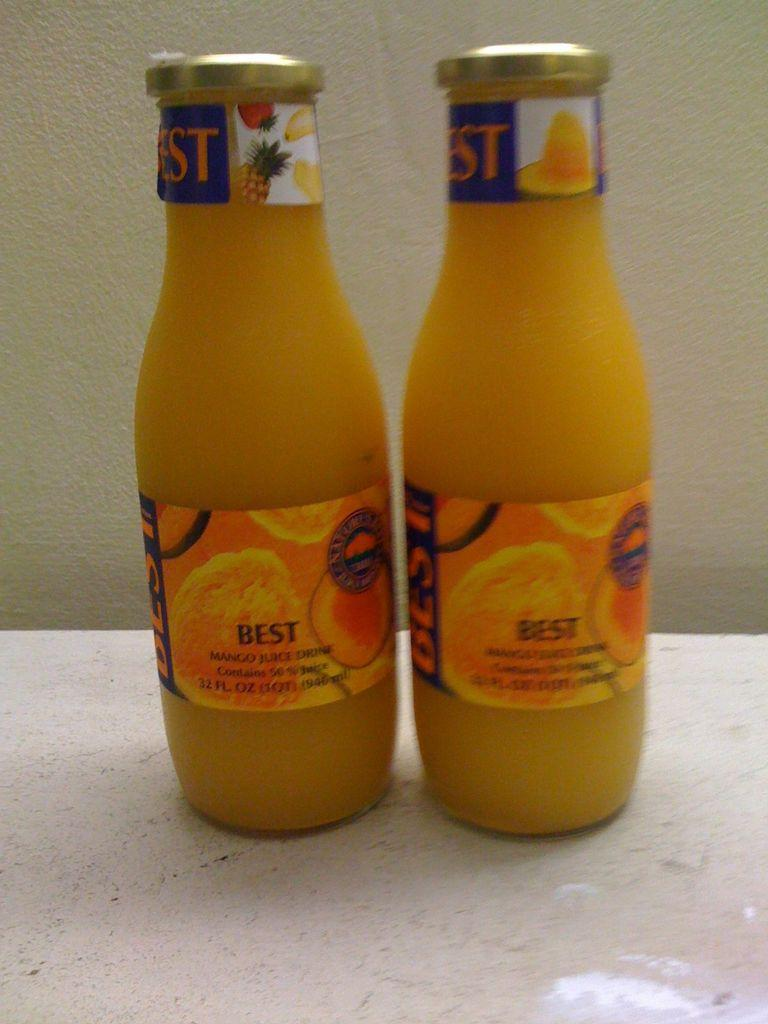<image>
Write a terse but informative summary of the picture. Two bottles of orange juice with the word best on them 